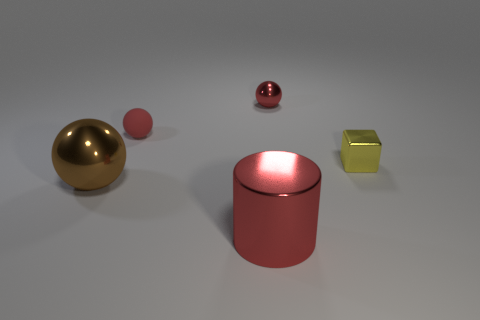How do the colors of these objects influence the mood of the image? The colors, ranging from a rich gold to a muted pink and contrasting with the bright yellow, create a palette that is modern and sophisticated. This color scheme, complemented by the soft lighting, evokes a serene and contemplative mood. 